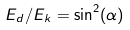Convert formula to latex. <formula><loc_0><loc_0><loc_500><loc_500>E _ { d } / E _ { k } = \sin ^ { 2 } ( \alpha )</formula> 